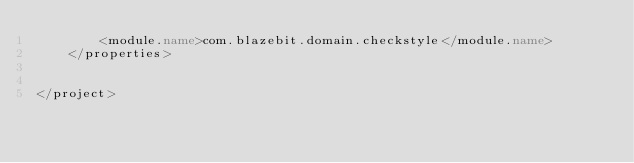Convert code to text. <code><loc_0><loc_0><loc_500><loc_500><_XML_>        <module.name>com.blazebit.domain.checkstyle</module.name>
    </properties>


</project></code> 